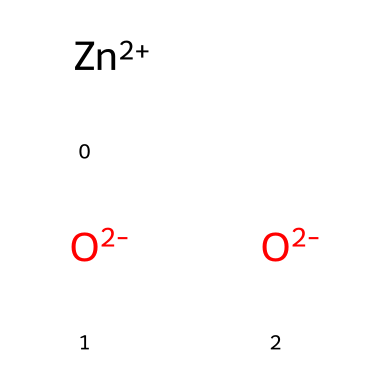What is the total number of atoms in this chemical structure? The SMILES representation shows two oxide ions (O) and one zinc ion (Zn). Thus, counting these gives a total of three distinct atoms in the structure.
Answer: three How many zinc ions are present in this structure? From the SMILES notation, it can be seen that there is one zinc ion [Zn+2], indicating that only one zinc atom is present in the chemical structure.
Answer: one What type of nanoparticle is represented by this chemical structure? The presence of zinc and oxygen in this chemical structure corresponds to zinc oxide, which is commonly classified as a metal oxide nanoparticle used in air purification systems.
Answer: zinc oxide What is the charge of the zinc ion in this structure? The SMILES notation specifies the zinc ion as [Zn+2], indicating it has a +2 charge. This shows the oxidation state of zinc in this particular nanoparticle.
Answer: +2 How many oxygen atoms are present in the structure? The chemical structure contains two oxide ions (as indicated by the two instances of [O-2]), meaning there are two oxygen atoms present in the compound.
Answer: two Why is zinc oxide effective in air purification systems? Zinc oxide has a wide bandgap and possesses photocatalytic properties, allowing it to break down pollutants in the air under UV light exposure. This quality makes it very effective for air purification applications.
Answer: photocatalytic properties What makes zinc oxide nanoparticles useful in biological applications? Zinc oxide nanoparticles exhibit antimicrobial properties due to their high surface area and ability to generate reactive oxygen species, which can disrupt microbial cell membranes. This property makes them useful in various biological applications.
Answer: antimicrobial properties 